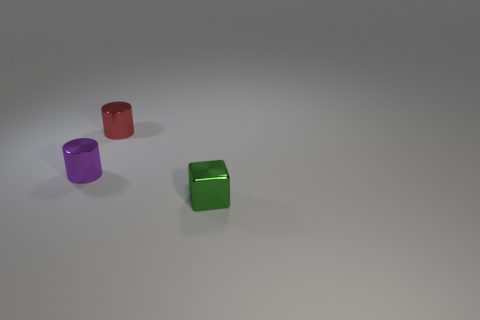Add 3 green shiny cubes. How many objects exist? 6 Subtract all cylinders. How many objects are left? 1 Add 2 big brown shiny spheres. How many big brown shiny spheres exist? 2 Subtract 0 brown cylinders. How many objects are left? 3 Subtract all small yellow shiny blocks. Subtract all tiny shiny cubes. How many objects are left? 2 Add 3 green blocks. How many green blocks are left? 4 